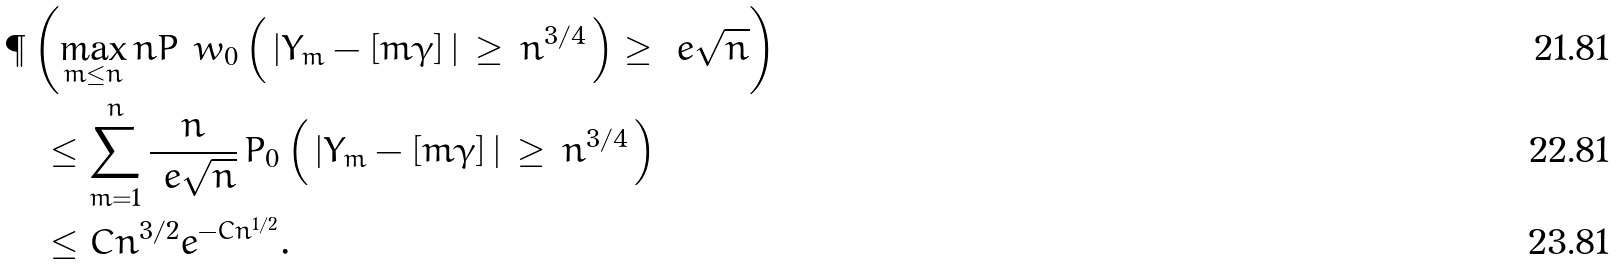Convert formula to latex. <formula><loc_0><loc_0><loc_500><loc_500>& \P \left ( \max _ { m \leq n } n P ^ { \ } w _ { 0 } \left ( \, | Y _ { m } - [ m \gamma ] \, | \, \geq \, n ^ { 3 / 4 } \, \right ) \geq \ e \sqrt { n } \right ) \\ & \quad \leq \sum _ { m = 1 } ^ { n } \frac { n } { \ e \sqrt { n } } \, P _ { 0 } \left ( \, | Y _ { m } - [ m \gamma ] \, | \, \geq \, n ^ { 3 / 4 } \, \right ) \\ & \quad \leq C n ^ { 3 / 2 } e ^ { - C n ^ { 1 / 2 } } .</formula> 